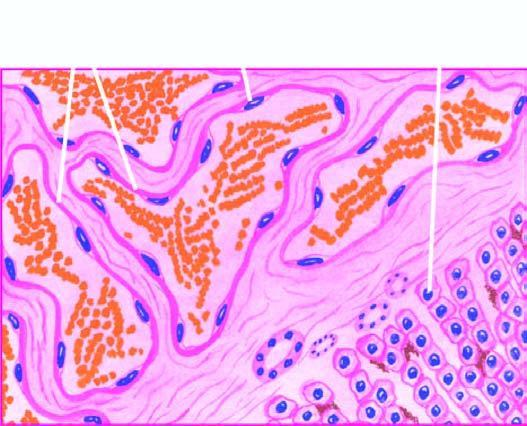re some macrophages large, dilated, many containing blood, and are lined by flattened endothelial cells?
Answer the question using a single word or phrase. No 